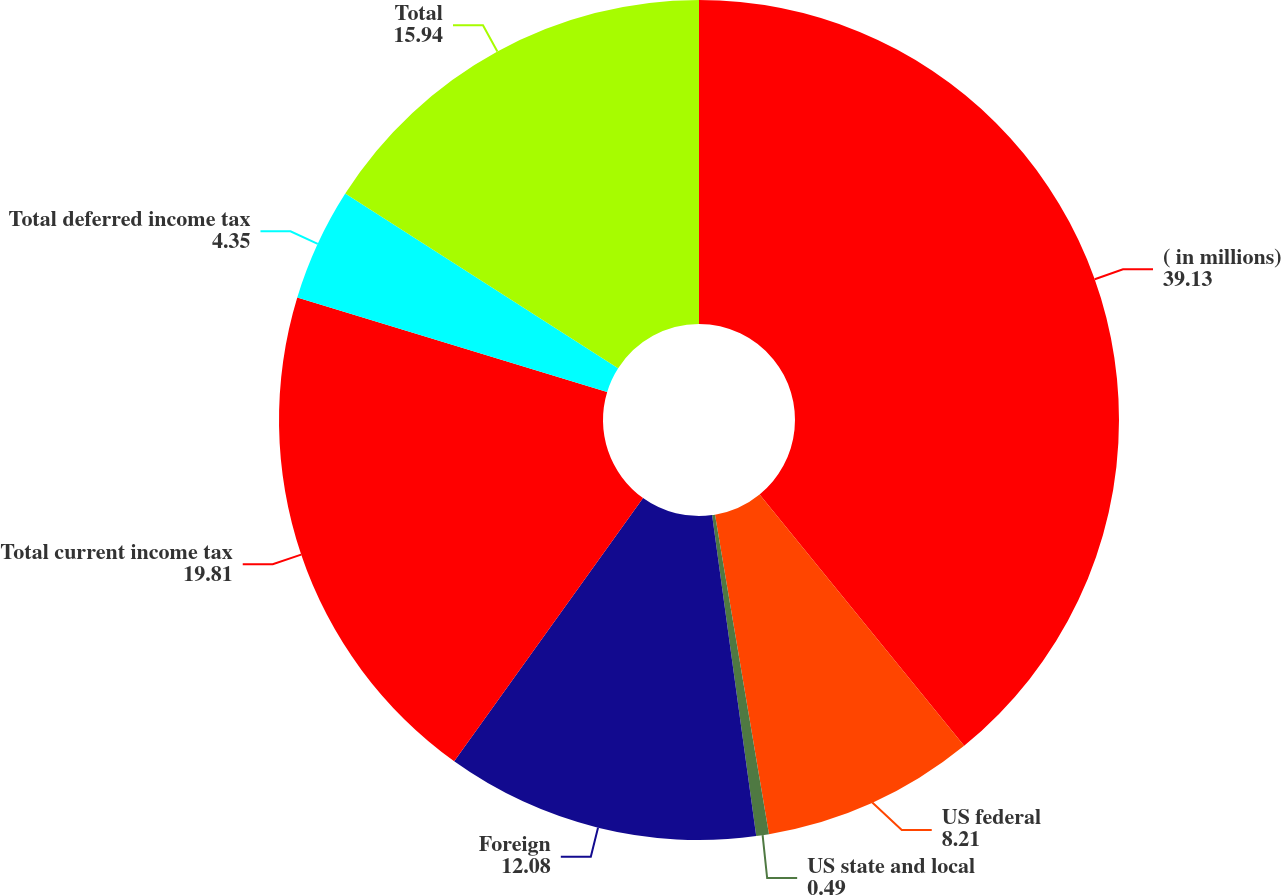Convert chart to OTSL. <chart><loc_0><loc_0><loc_500><loc_500><pie_chart><fcel>( in millions)<fcel>US federal<fcel>US state and local<fcel>Foreign<fcel>Total current income tax<fcel>Total deferred income tax<fcel>Total<nl><fcel>39.13%<fcel>8.21%<fcel>0.49%<fcel>12.08%<fcel>19.81%<fcel>4.35%<fcel>15.94%<nl></chart> 